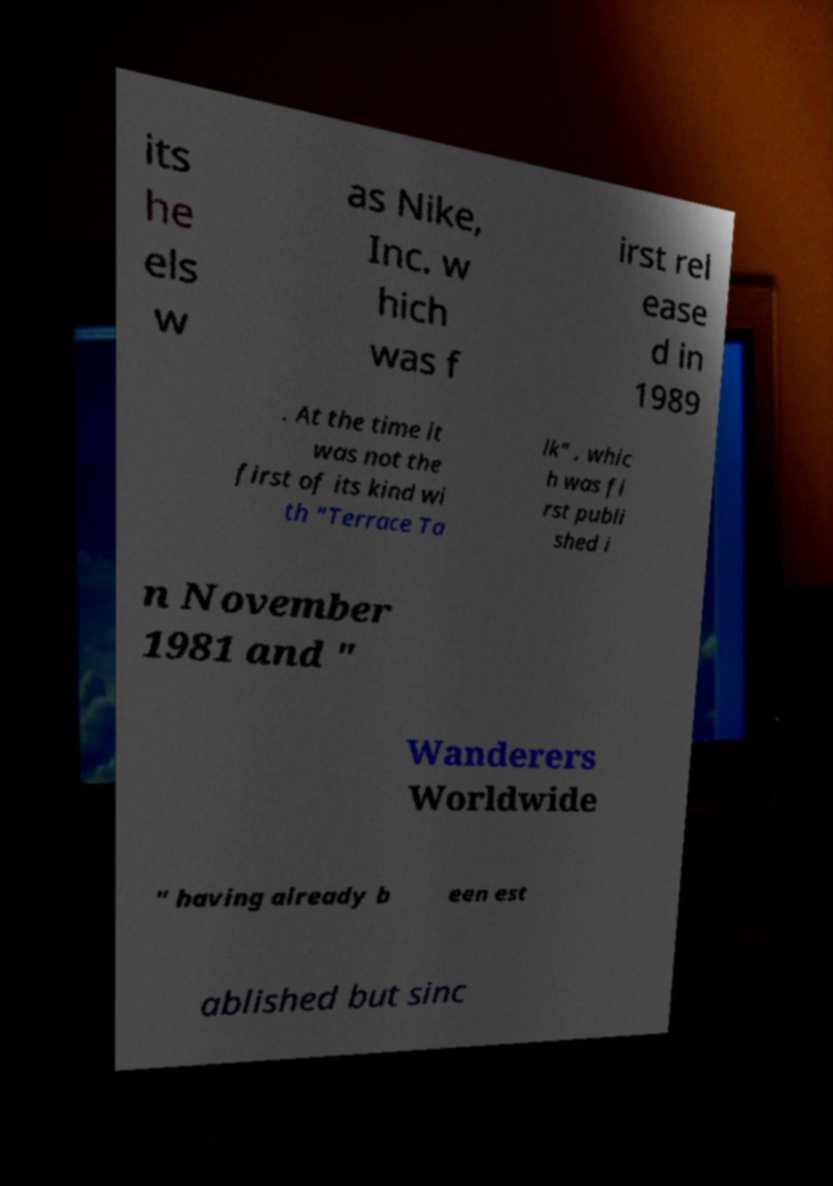There's text embedded in this image that I need extracted. Can you transcribe it verbatim? its he els w as Nike, Inc. w hich was f irst rel ease d in 1989 . At the time it was not the first of its kind wi th "Terrace Ta lk" , whic h was fi rst publi shed i n November 1981 and " Wanderers Worldwide " having already b een est ablished but sinc 